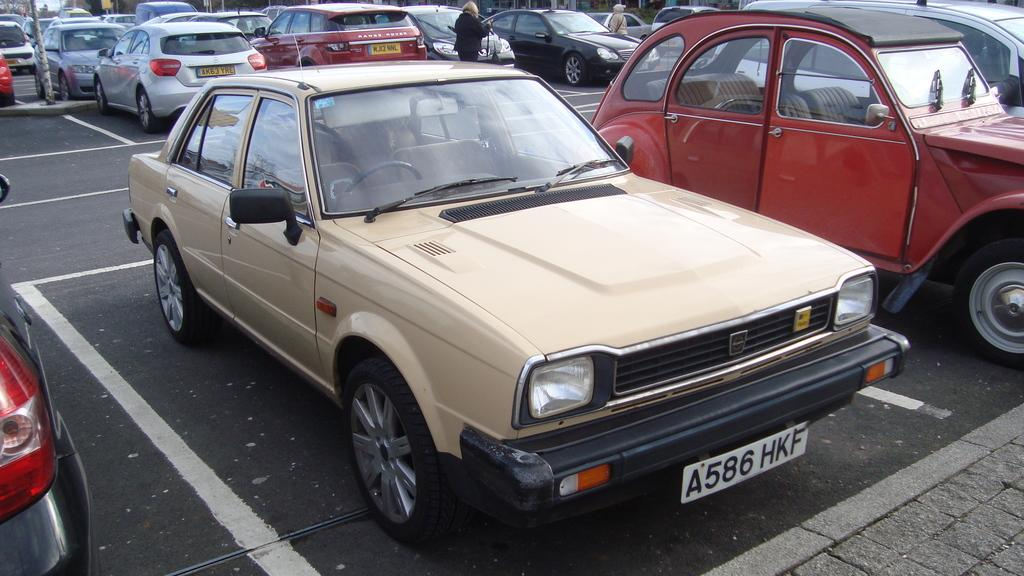What can be seen in the image related to transportation? There are vehicles parked in the image. Can you describe the people in the image? There are two persons at the top of the image. What is located in the top left corner of the image? There is a pole in the top left corner of the image. What type of weather can be seen in the image? There is no information about the weather in the image. Can you describe the coil used by the persons in the image? There is no coil present in the image. 